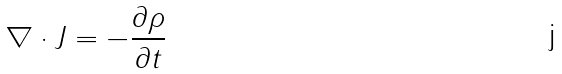<formula> <loc_0><loc_0><loc_500><loc_500>\nabla \cdot J = - \frac { \partial \rho } { \partial t }</formula> 